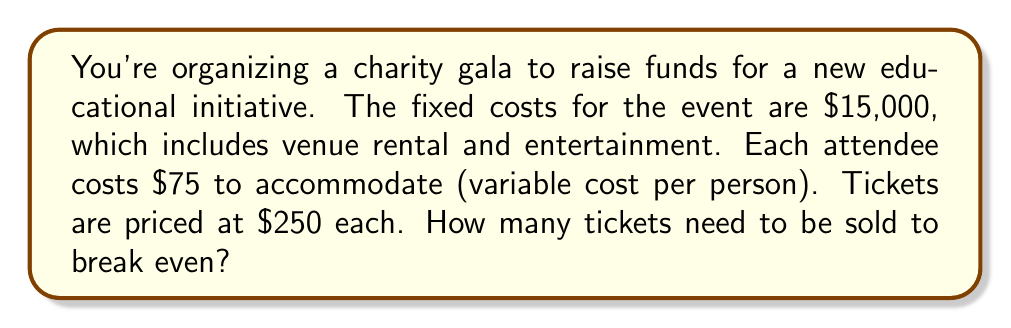Teach me how to tackle this problem. To calculate the break-even point, we need to determine the number of tickets that must be sold for the total revenue to equal the total costs. Let's approach this step-by-step:

1. Define variables:
   Let $x$ = number of tickets sold
   Fixed costs (FC) = $15,000
   Variable cost per ticket (VC) = $75
   Price per ticket (P) = $250

2. Set up the break-even equation:
   Total Revenue = Total Costs
   $Px = FC + VCx$

3. Substitute the known values:
   $250x = 15,000 + 75x$

4. Solve for $x$:
   $250x - 75x = 15,000$
   $175x = 15,000$

5. Divide both sides by 175:
   $x = \frac{15,000}{175} = 85.71$

6. Since we can't sell a fraction of a ticket, we round up to the nearest whole number:
   $x = 86$

Therefore, 86 tickets need to be sold to break even.
Answer: 86 tickets 